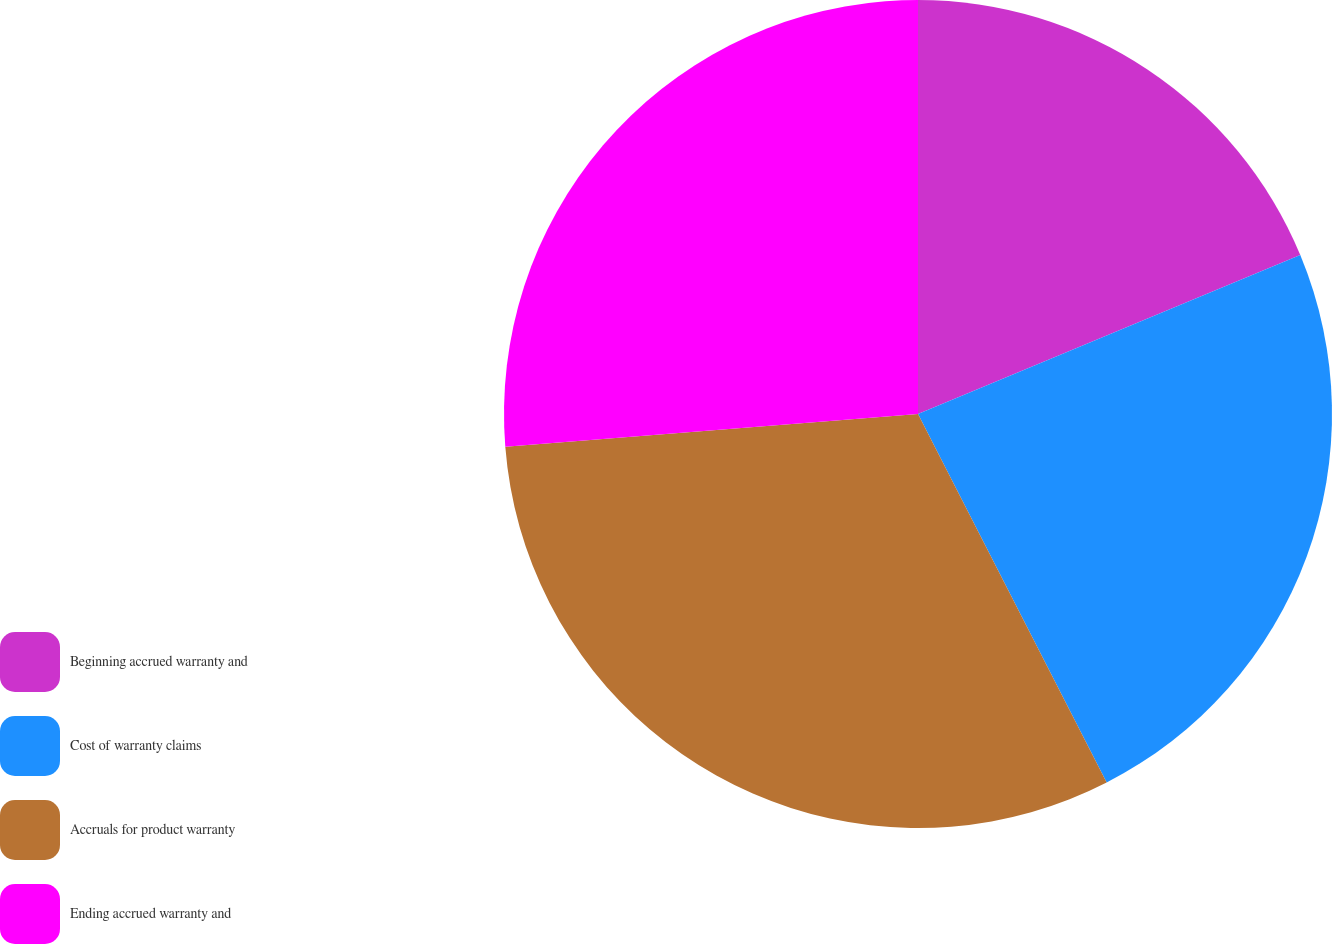Convert chart to OTSL. <chart><loc_0><loc_0><loc_500><loc_500><pie_chart><fcel>Beginning accrued warranty and<fcel>Cost of warranty claims<fcel>Accruals for product warranty<fcel>Ending accrued warranty and<nl><fcel>18.73%<fcel>23.74%<fcel>31.27%<fcel>26.26%<nl></chart> 